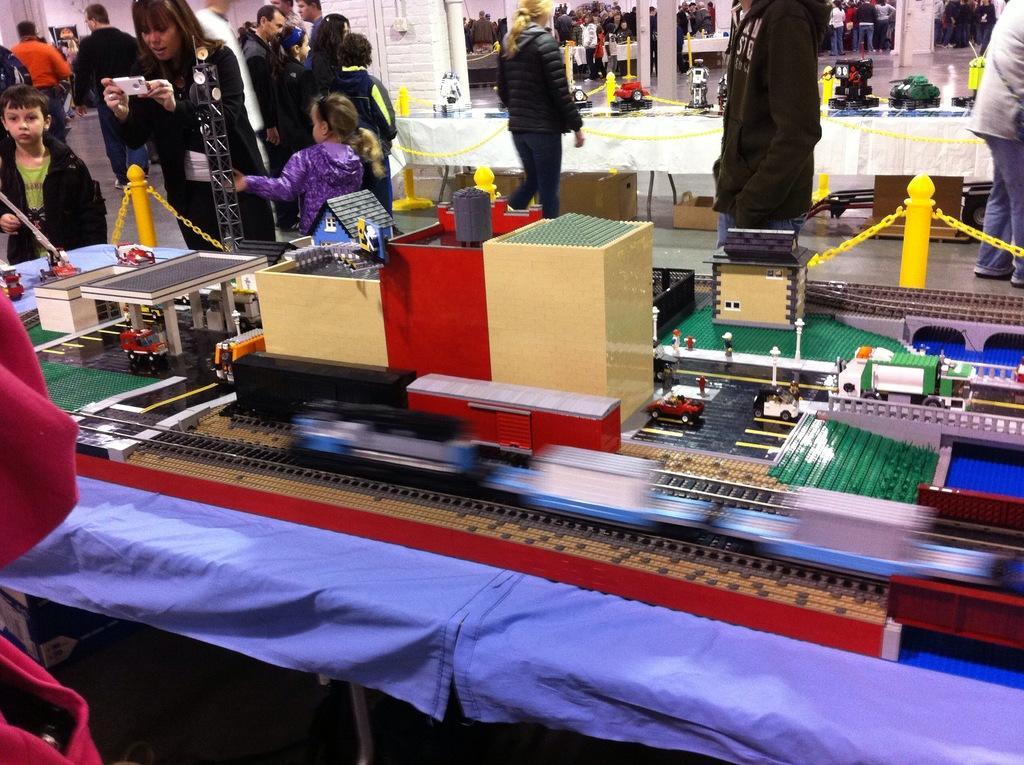Please provide a concise description of this image. In the picture I can see some toys are placed on the table, I can see children and people are walking on the floor, I can see few more tables, pillars and the wall in the background. 